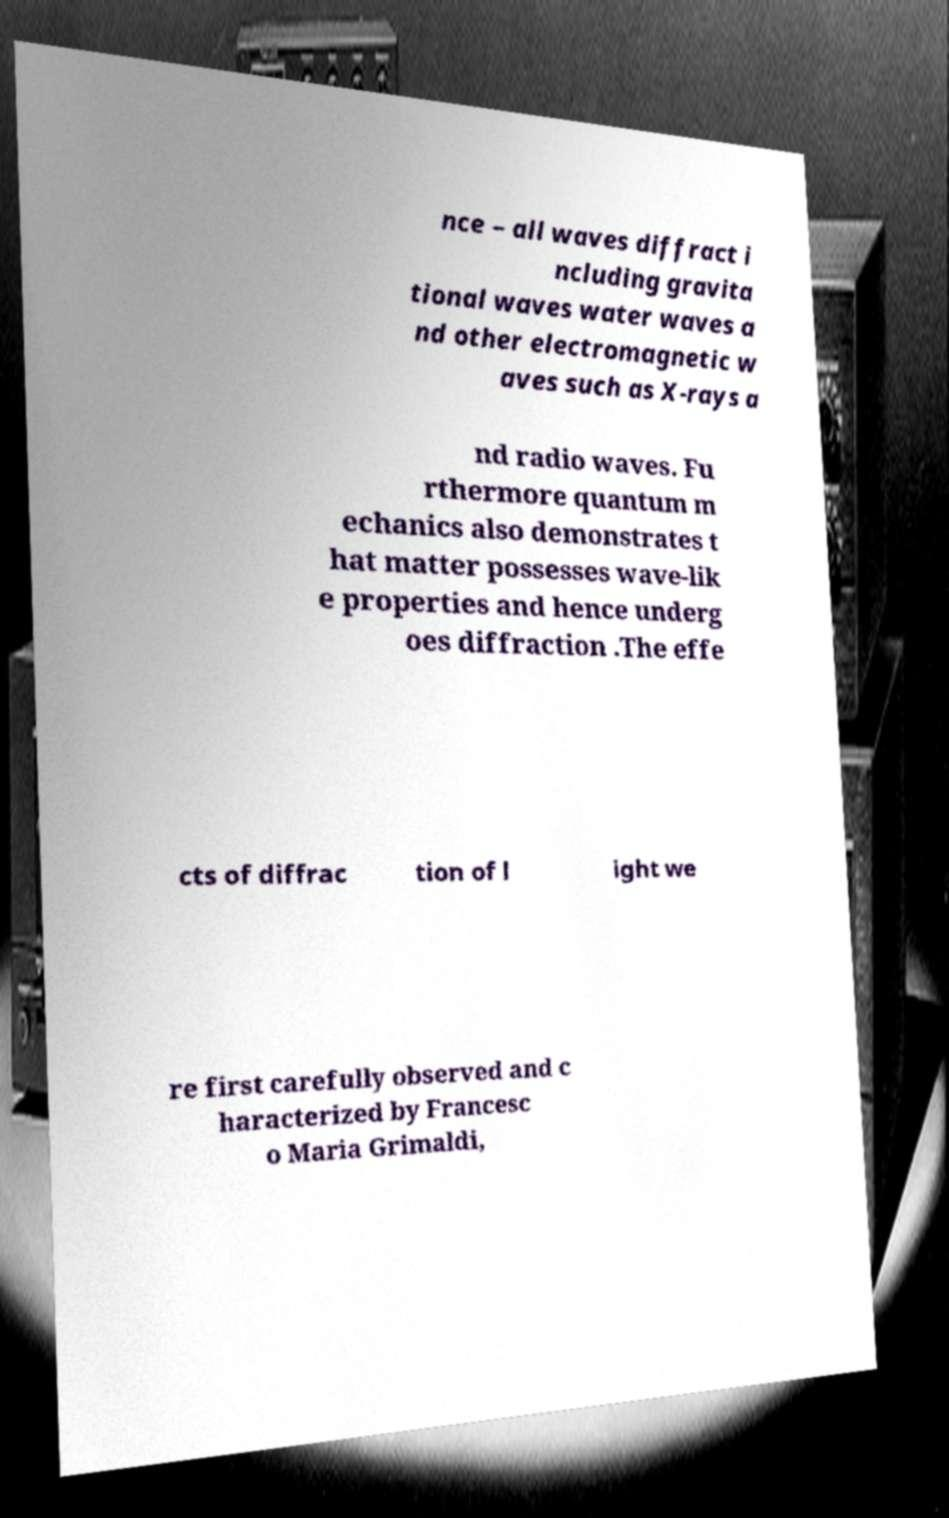For documentation purposes, I need the text within this image transcribed. Could you provide that? nce – all waves diffract i ncluding gravita tional waves water waves a nd other electromagnetic w aves such as X-rays a nd radio waves. Fu rthermore quantum m echanics also demonstrates t hat matter possesses wave-lik e properties and hence underg oes diffraction .The effe cts of diffrac tion of l ight we re first carefully observed and c haracterized by Francesc o Maria Grimaldi, 